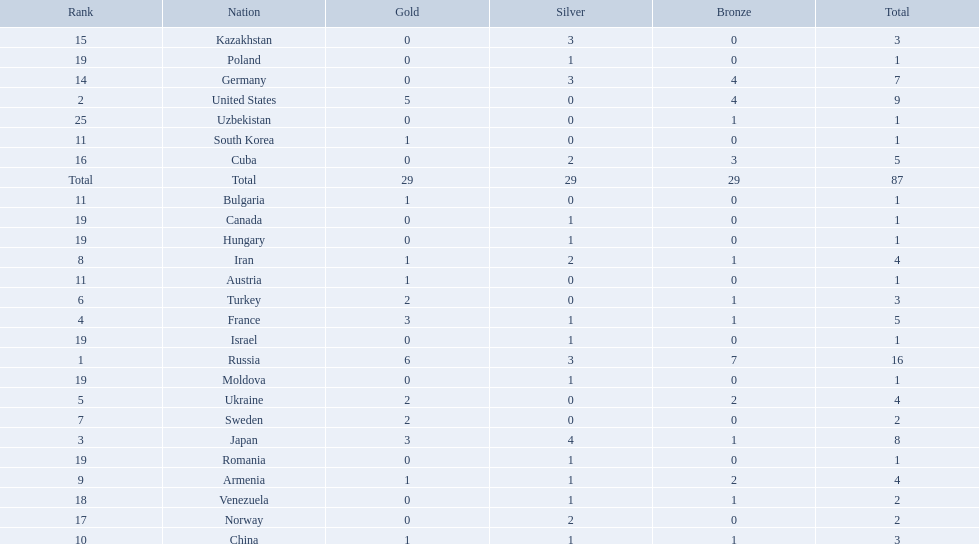Which countries competed in the 1995 world wrestling championships? Russia, United States, Japan, France, Ukraine, Turkey, Sweden, Iran, Armenia, China, Austria, Bulgaria, South Korea, Germany, Kazakhstan, Cuba, Norway, Venezuela, Canada, Hungary, Israel, Moldova, Poland, Romania, Uzbekistan. What country won only one medal? Austria, Bulgaria, South Korea, Canada, Hungary, Israel, Moldova, Poland, Romania, Uzbekistan. Which of these won a bronze medal? Uzbekistan. 